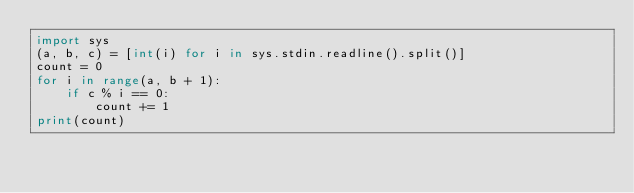<code> <loc_0><loc_0><loc_500><loc_500><_Python_>import sys
(a, b, c) = [int(i) for i in sys.stdin.readline().split()]
count = 0
for i in range(a, b + 1):
    if c % i == 0:
        count += 1
print(count)</code> 